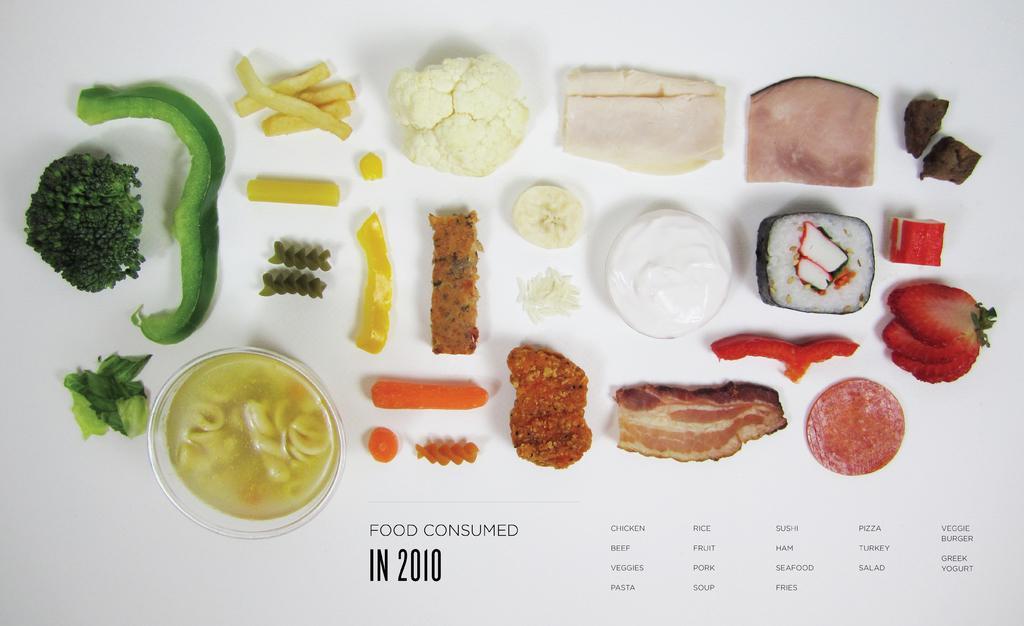Please provide a concise description of this image. In the picture there are different vegetables,fruits and meat are kept and the picture is taken from some website. 